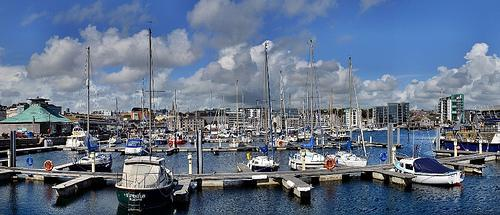Question: where was this photo taken?
Choices:
A. At a ski resort.
B. At a race track.
C. At an airport.
D. At a marina.
Answer with the letter. Answer: D Question: what mode of transportation is viewable?
Choices:
A. Boats.
B. Cars.
C. Bikes.
D. Skateboard.
Answer with the letter. Answer: A Question: what is the color of the roof on the left?
Choices:
A. Red.
B. Green.
C. Orange.
D. Grey.
Answer with the letter. Answer: B Question: how does the sky look?
Choices:
A. Partly cloudy.
B. Sunny.
C. Overcast.
D. Densely Cloudy.
Answer with the letter. Answer: A Question: what is in the background?
Choices:
A. Homes.
B. Schools.
C. Churches.
D. Buildings.
Answer with the letter. Answer: D Question: what color does the water look?
Choices:
A. Blue.
B. Green.
C. White.
D. Grey.
Answer with the letter. Answer: A 